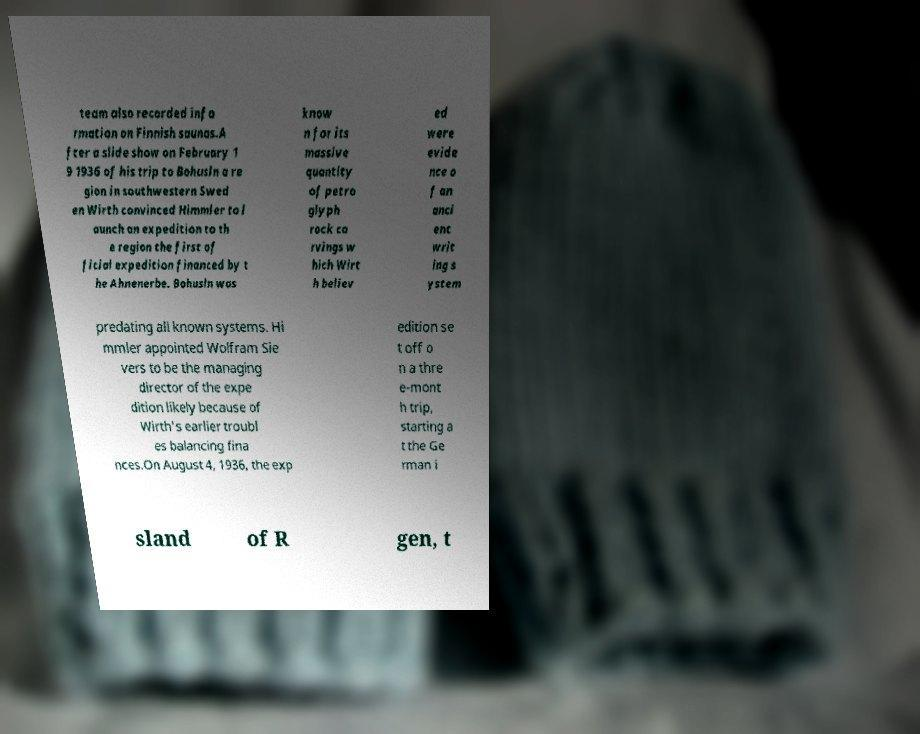Please read and relay the text visible in this image. What does it say? team also recorded info rmation on Finnish saunas.A fter a slide show on February 1 9 1936 of his trip to Bohusln a re gion in southwestern Swed en Wirth convinced Himmler to l aunch an expedition to th e region the first of ficial expedition financed by t he Ahnenerbe. Bohusln was know n for its massive quantity of petro glyph rock ca rvings w hich Wirt h believ ed were evide nce o f an anci ent writ ing s ystem predating all known systems. Hi mmler appointed Wolfram Sie vers to be the managing director of the expe dition likely because of Wirth's earlier troubl es balancing fina nces.On August 4, 1936, the exp edition se t off o n a thre e-mont h trip, starting a t the Ge rman i sland of R gen, t 